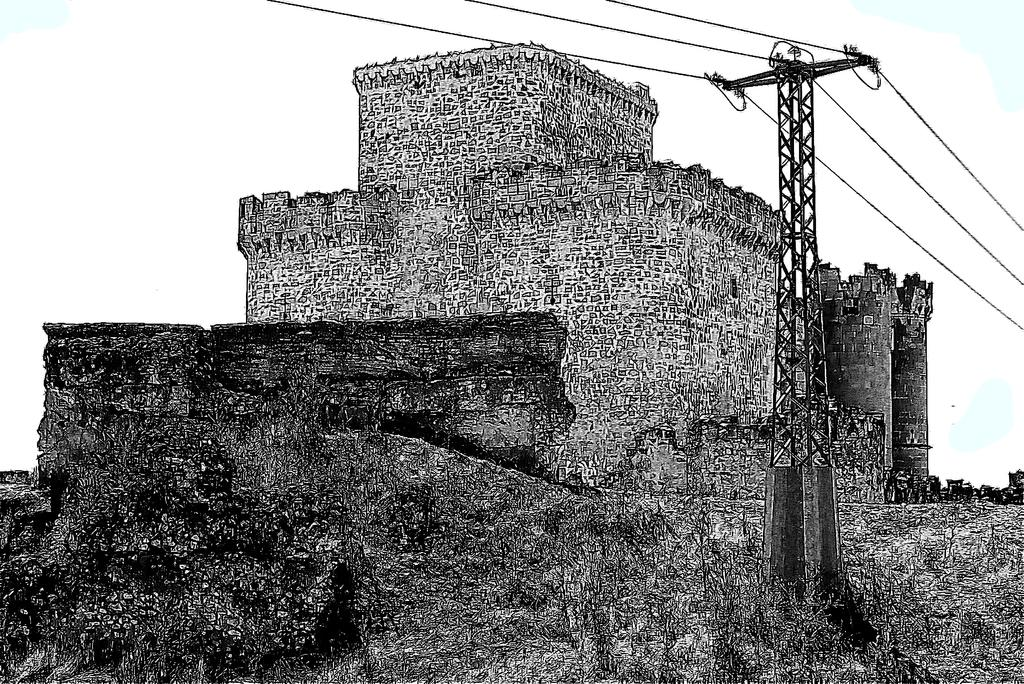What is the color scheme of the image? The image is black and white. What type of structure can be seen in the image? There is a fort in the image. What else is present in the image besides the fort? There is an electric pole with wires in the image. What can be seen in the background of the image? The sky is visible in the background of the image. What type of grape is being traded between the fort and the electric pole in the image? There is no grape or trade activity present in the image. 